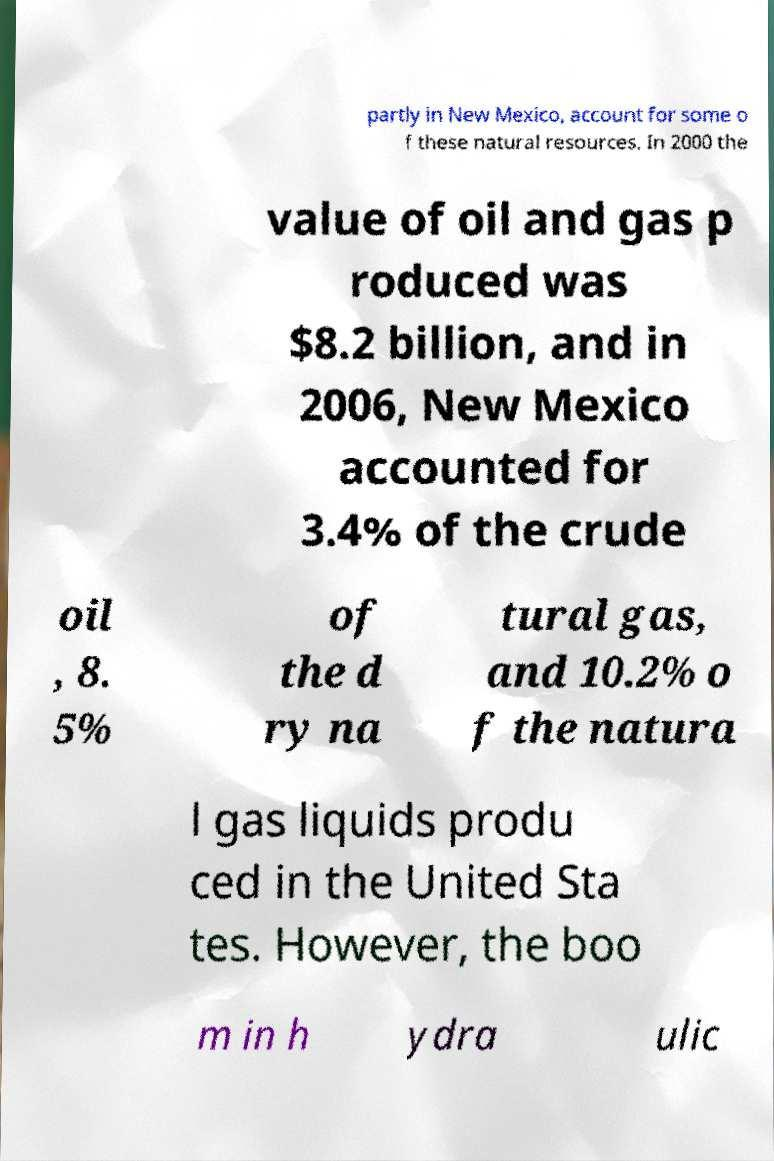Could you extract and type out the text from this image? partly in New Mexico, account for some o f these natural resources. In 2000 the value of oil and gas p roduced was $8.2 billion, and in 2006, New Mexico accounted for 3.4% of the crude oil , 8. 5% of the d ry na tural gas, and 10.2% o f the natura l gas liquids produ ced in the United Sta tes. However, the boo m in h ydra ulic 